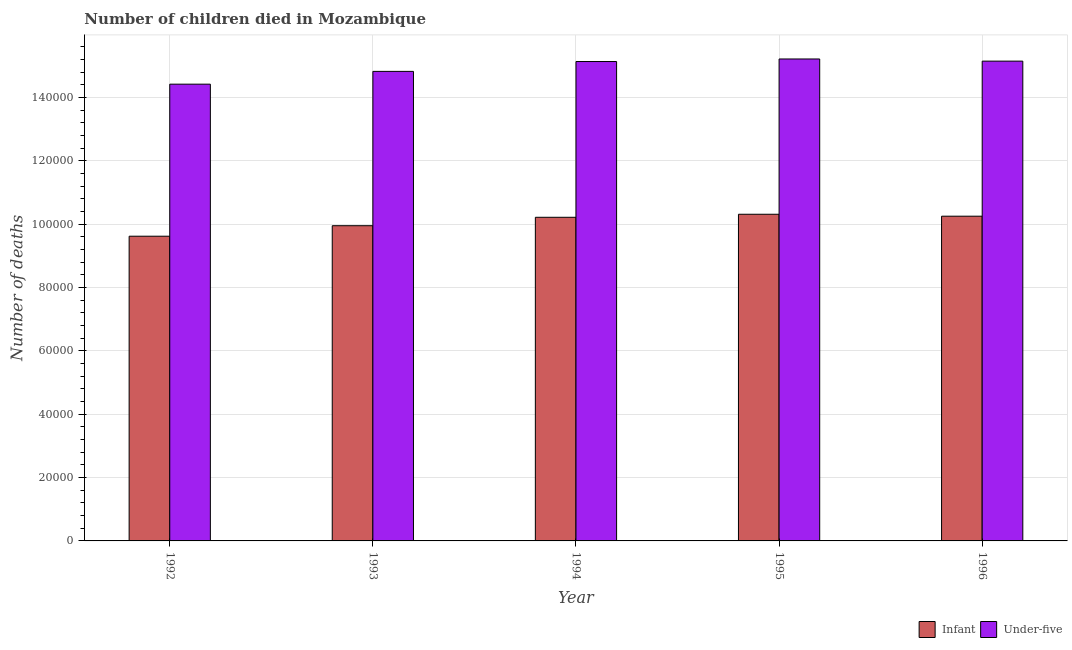How many different coloured bars are there?
Offer a very short reply. 2. Are the number of bars on each tick of the X-axis equal?
Your answer should be compact. Yes. How many bars are there on the 5th tick from the right?
Ensure brevity in your answer.  2. What is the label of the 2nd group of bars from the left?
Give a very brief answer. 1993. In how many cases, is the number of bars for a given year not equal to the number of legend labels?
Offer a very short reply. 0. What is the number of under-five deaths in 1994?
Make the answer very short. 1.51e+05. Across all years, what is the maximum number of under-five deaths?
Keep it short and to the point. 1.52e+05. Across all years, what is the minimum number of under-five deaths?
Keep it short and to the point. 1.44e+05. In which year was the number of infant deaths minimum?
Your answer should be very brief. 1992. What is the total number of infant deaths in the graph?
Your response must be concise. 5.03e+05. What is the difference between the number of infant deaths in 1994 and that in 1996?
Keep it short and to the point. -346. What is the difference between the number of under-five deaths in 1992 and the number of infant deaths in 1993?
Make the answer very short. -4032. What is the average number of under-five deaths per year?
Give a very brief answer. 1.49e+05. What is the ratio of the number of under-five deaths in 1992 to that in 1995?
Your response must be concise. 0.95. Is the number of infant deaths in 1993 less than that in 1994?
Offer a terse response. Yes. Is the difference between the number of infant deaths in 1992 and 1995 greater than the difference between the number of under-five deaths in 1992 and 1995?
Your answer should be very brief. No. What is the difference between the highest and the second highest number of infant deaths?
Make the answer very short. 610. What is the difference between the highest and the lowest number of under-five deaths?
Provide a succinct answer. 7951. Is the sum of the number of under-five deaths in 1995 and 1996 greater than the maximum number of infant deaths across all years?
Provide a short and direct response. Yes. What does the 2nd bar from the left in 1996 represents?
Your response must be concise. Under-five. What does the 2nd bar from the right in 1992 represents?
Your answer should be very brief. Infant. Does the graph contain any zero values?
Your answer should be very brief. No. Where does the legend appear in the graph?
Your answer should be compact. Bottom right. How are the legend labels stacked?
Offer a terse response. Horizontal. What is the title of the graph?
Provide a short and direct response. Number of children died in Mozambique. Does "GDP per capita" appear as one of the legend labels in the graph?
Ensure brevity in your answer.  No. What is the label or title of the Y-axis?
Your answer should be very brief. Number of deaths. What is the Number of deaths in Infant in 1992?
Your answer should be compact. 9.62e+04. What is the Number of deaths in Under-five in 1992?
Your response must be concise. 1.44e+05. What is the Number of deaths of Infant in 1993?
Give a very brief answer. 9.95e+04. What is the Number of deaths of Under-five in 1993?
Provide a succinct answer. 1.48e+05. What is the Number of deaths of Infant in 1994?
Provide a short and direct response. 1.02e+05. What is the Number of deaths in Under-five in 1994?
Give a very brief answer. 1.51e+05. What is the Number of deaths of Infant in 1995?
Make the answer very short. 1.03e+05. What is the Number of deaths of Under-five in 1995?
Make the answer very short. 1.52e+05. What is the Number of deaths in Infant in 1996?
Provide a succinct answer. 1.02e+05. What is the Number of deaths in Under-five in 1996?
Ensure brevity in your answer.  1.51e+05. Across all years, what is the maximum Number of deaths of Infant?
Offer a very short reply. 1.03e+05. Across all years, what is the maximum Number of deaths of Under-five?
Your answer should be compact. 1.52e+05. Across all years, what is the minimum Number of deaths in Infant?
Offer a very short reply. 9.62e+04. Across all years, what is the minimum Number of deaths of Under-five?
Give a very brief answer. 1.44e+05. What is the total Number of deaths of Infant in the graph?
Your answer should be very brief. 5.03e+05. What is the total Number of deaths of Under-five in the graph?
Offer a terse response. 7.47e+05. What is the difference between the Number of deaths in Infant in 1992 and that in 1993?
Offer a terse response. -3313. What is the difference between the Number of deaths in Under-five in 1992 and that in 1993?
Your response must be concise. -4032. What is the difference between the Number of deaths of Infant in 1992 and that in 1994?
Ensure brevity in your answer.  -5971. What is the difference between the Number of deaths of Under-five in 1992 and that in 1994?
Provide a short and direct response. -7147. What is the difference between the Number of deaths in Infant in 1992 and that in 1995?
Ensure brevity in your answer.  -6927. What is the difference between the Number of deaths in Under-five in 1992 and that in 1995?
Offer a very short reply. -7951. What is the difference between the Number of deaths in Infant in 1992 and that in 1996?
Your answer should be very brief. -6317. What is the difference between the Number of deaths of Under-five in 1992 and that in 1996?
Provide a succinct answer. -7267. What is the difference between the Number of deaths in Infant in 1993 and that in 1994?
Offer a terse response. -2658. What is the difference between the Number of deaths in Under-five in 1993 and that in 1994?
Give a very brief answer. -3115. What is the difference between the Number of deaths in Infant in 1993 and that in 1995?
Make the answer very short. -3614. What is the difference between the Number of deaths of Under-five in 1993 and that in 1995?
Your answer should be very brief. -3919. What is the difference between the Number of deaths of Infant in 1993 and that in 1996?
Keep it short and to the point. -3004. What is the difference between the Number of deaths in Under-five in 1993 and that in 1996?
Your response must be concise. -3235. What is the difference between the Number of deaths in Infant in 1994 and that in 1995?
Ensure brevity in your answer.  -956. What is the difference between the Number of deaths in Under-five in 1994 and that in 1995?
Provide a short and direct response. -804. What is the difference between the Number of deaths of Infant in 1994 and that in 1996?
Offer a very short reply. -346. What is the difference between the Number of deaths of Under-five in 1994 and that in 1996?
Give a very brief answer. -120. What is the difference between the Number of deaths of Infant in 1995 and that in 1996?
Offer a very short reply. 610. What is the difference between the Number of deaths in Under-five in 1995 and that in 1996?
Provide a succinct answer. 684. What is the difference between the Number of deaths of Infant in 1992 and the Number of deaths of Under-five in 1993?
Give a very brief answer. -5.20e+04. What is the difference between the Number of deaths of Infant in 1992 and the Number of deaths of Under-five in 1994?
Offer a very short reply. -5.51e+04. What is the difference between the Number of deaths in Infant in 1992 and the Number of deaths in Under-five in 1995?
Keep it short and to the point. -5.59e+04. What is the difference between the Number of deaths in Infant in 1992 and the Number of deaths in Under-five in 1996?
Provide a short and direct response. -5.53e+04. What is the difference between the Number of deaths in Infant in 1993 and the Number of deaths in Under-five in 1994?
Ensure brevity in your answer.  -5.18e+04. What is the difference between the Number of deaths of Infant in 1993 and the Number of deaths of Under-five in 1995?
Offer a terse response. -5.26e+04. What is the difference between the Number of deaths in Infant in 1993 and the Number of deaths in Under-five in 1996?
Keep it short and to the point. -5.19e+04. What is the difference between the Number of deaths in Infant in 1994 and the Number of deaths in Under-five in 1995?
Provide a succinct answer. -5.00e+04. What is the difference between the Number of deaths in Infant in 1994 and the Number of deaths in Under-five in 1996?
Provide a short and direct response. -4.93e+04. What is the difference between the Number of deaths of Infant in 1995 and the Number of deaths of Under-five in 1996?
Your answer should be compact. -4.83e+04. What is the average Number of deaths in Infant per year?
Make the answer very short. 1.01e+05. What is the average Number of deaths of Under-five per year?
Your answer should be compact. 1.49e+05. In the year 1992, what is the difference between the Number of deaths in Infant and Number of deaths in Under-five?
Give a very brief answer. -4.80e+04. In the year 1993, what is the difference between the Number of deaths in Infant and Number of deaths in Under-five?
Your response must be concise. -4.87e+04. In the year 1994, what is the difference between the Number of deaths of Infant and Number of deaths of Under-five?
Ensure brevity in your answer.  -4.92e+04. In the year 1995, what is the difference between the Number of deaths in Infant and Number of deaths in Under-five?
Make the answer very short. -4.90e+04. In the year 1996, what is the difference between the Number of deaths of Infant and Number of deaths of Under-five?
Offer a terse response. -4.89e+04. What is the ratio of the Number of deaths in Infant in 1992 to that in 1993?
Make the answer very short. 0.97. What is the ratio of the Number of deaths of Under-five in 1992 to that in 1993?
Make the answer very short. 0.97. What is the ratio of the Number of deaths of Infant in 1992 to that in 1994?
Make the answer very short. 0.94. What is the ratio of the Number of deaths of Under-five in 1992 to that in 1994?
Keep it short and to the point. 0.95. What is the ratio of the Number of deaths of Infant in 1992 to that in 1995?
Your response must be concise. 0.93. What is the ratio of the Number of deaths in Under-five in 1992 to that in 1995?
Provide a short and direct response. 0.95. What is the ratio of the Number of deaths of Infant in 1992 to that in 1996?
Offer a very short reply. 0.94. What is the ratio of the Number of deaths of Under-five in 1992 to that in 1996?
Your answer should be very brief. 0.95. What is the ratio of the Number of deaths of Under-five in 1993 to that in 1994?
Your answer should be compact. 0.98. What is the ratio of the Number of deaths of Infant in 1993 to that in 1995?
Ensure brevity in your answer.  0.96. What is the ratio of the Number of deaths in Under-five in 1993 to that in 1995?
Provide a short and direct response. 0.97. What is the ratio of the Number of deaths in Infant in 1993 to that in 1996?
Your answer should be compact. 0.97. What is the ratio of the Number of deaths of Under-five in 1993 to that in 1996?
Offer a very short reply. 0.98. What is the ratio of the Number of deaths in Infant in 1994 to that in 1995?
Give a very brief answer. 0.99. What is the ratio of the Number of deaths of Under-five in 1994 to that in 1996?
Offer a terse response. 1. What is the ratio of the Number of deaths in Under-five in 1995 to that in 1996?
Your answer should be very brief. 1. What is the difference between the highest and the second highest Number of deaths in Infant?
Keep it short and to the point. 610. What is the difference between the highest and the second highest Number of deaths of Under-five?
Provide a succinct answer. 684. What is the difference between the highest and the lowest Number of deaths in Infant?
Provide a short and direct response. 6927. What is the difference between the highest and the lowest Number of deaths in Under-five?
Provide a succinct answer. 7951. 